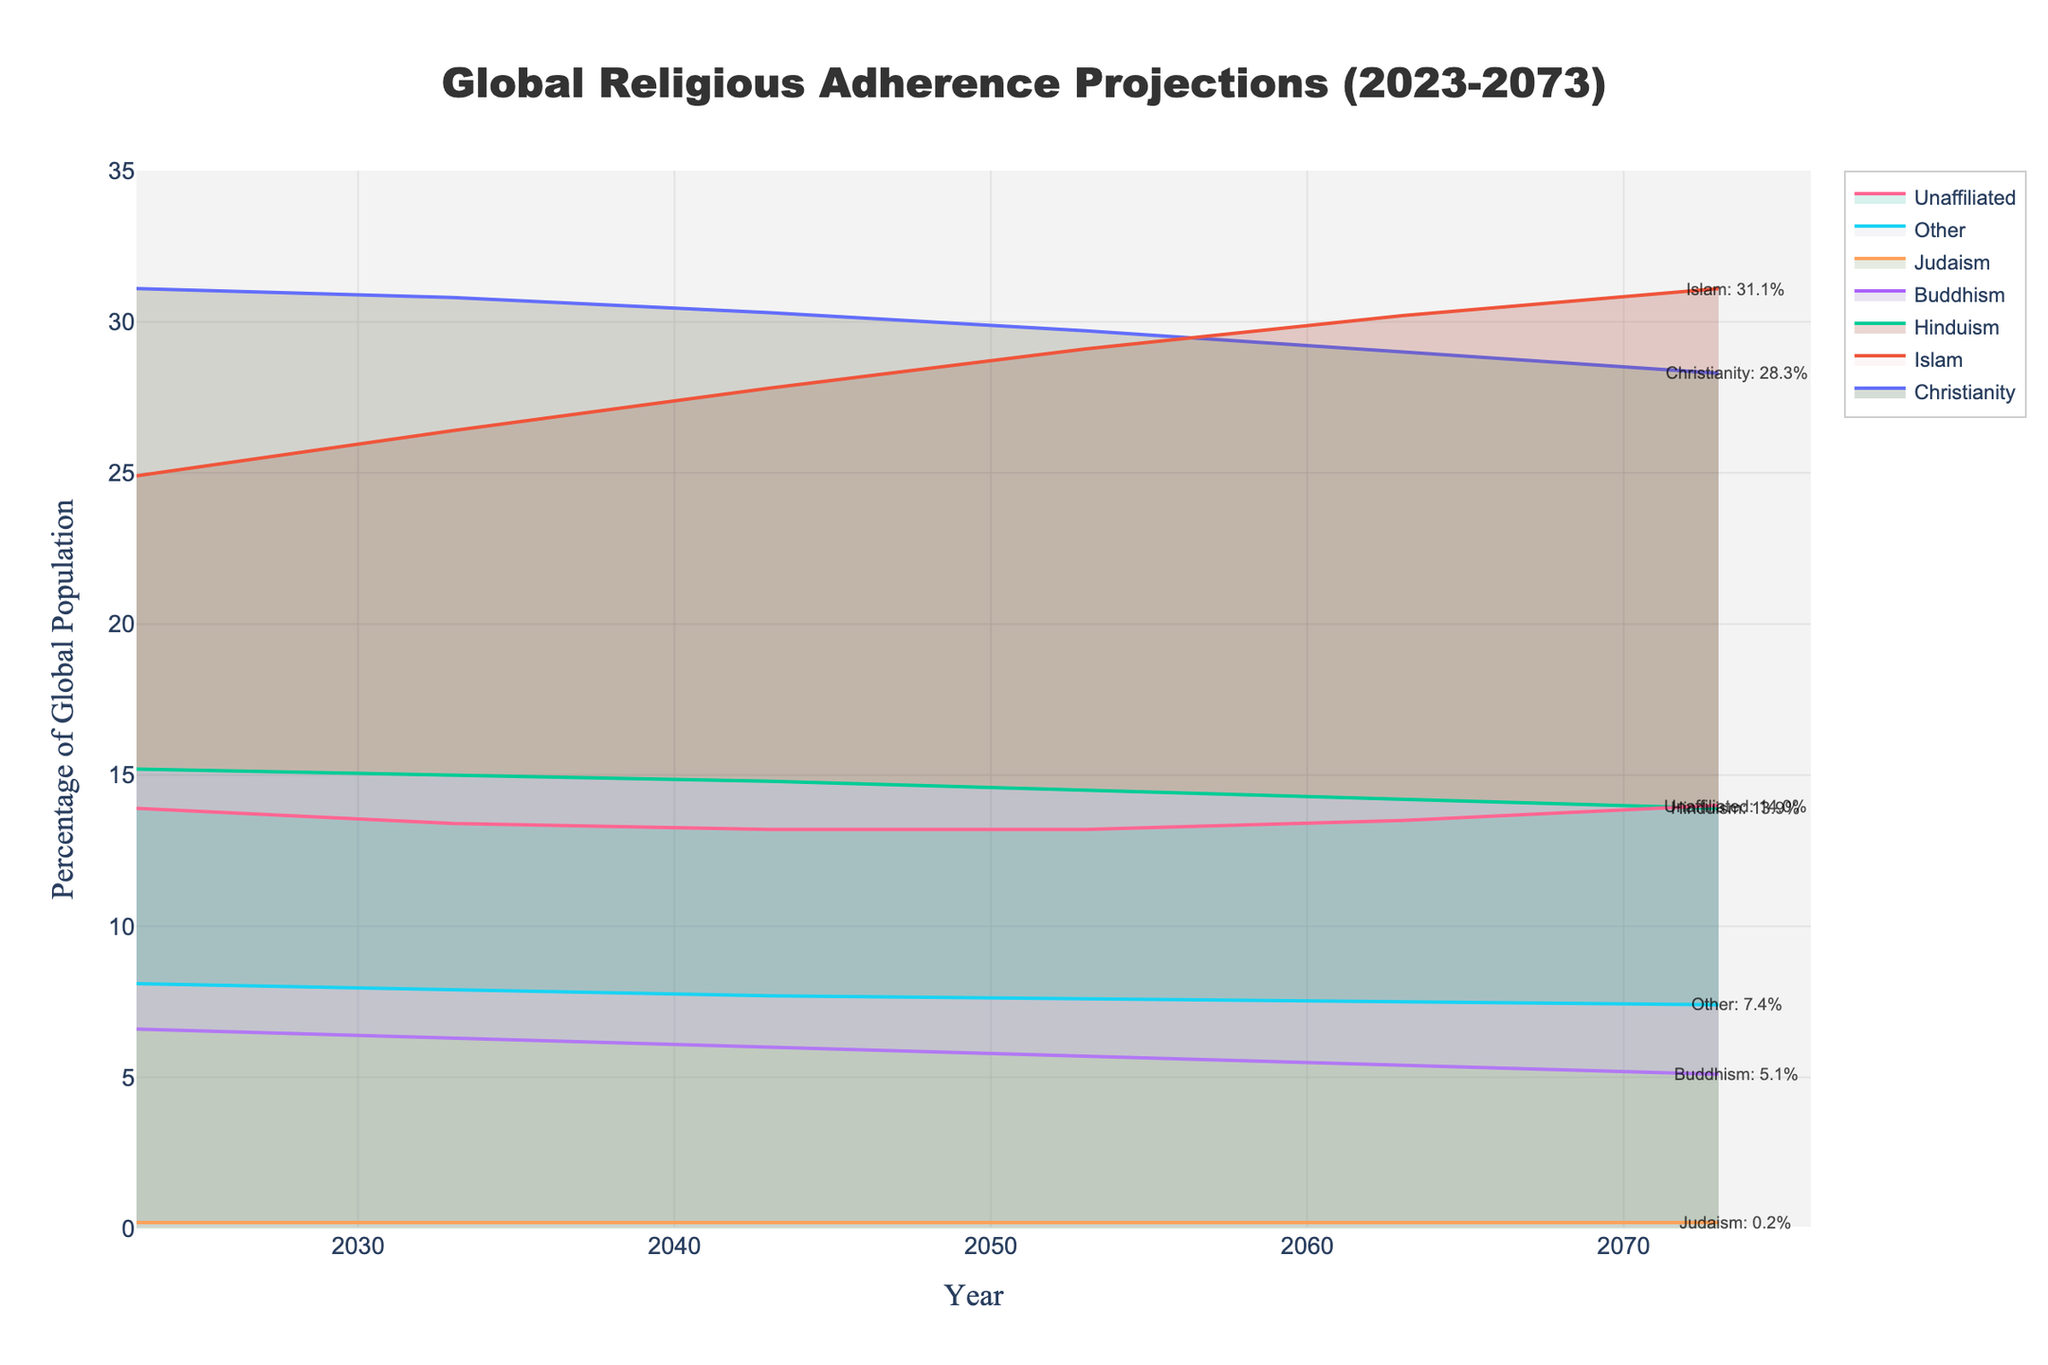What is the title of the figure? The title is typically displayed at the top of the figure. "Global Religious Adherence Projections (2023-2073)" is prominently shown in the code layout description.
Answer: Global Religious Adherence Projections (2023-2073) Which religion is projected to have the highest adherence in 2073? By visually scanning the lines in the chart and the annotations at the end of each line for the year 2073, Islam has the highest adherence at 31.1%.
Answer: Islam How much is the percentage of Christianity projected to decrease between 2023 and 2073? The chart shows the line for Christianity starting at 31.1% in 2023 and decreasing to 28.3% in 2073. The decrease can be calculated as 31.1% - 28.3% = 2.8%.
Answer: 2.8% What is the overall trend for the percentage of unaffiliated individuals? The line for 'Unaffiliated' shows a gradual increase, starting from 13.9% in 2023 and rising to 14.0% in 2073.
Answer: Gradually increasing In what year is the percentage of Buddhism projected to be 5.7%? Following the trend lines in the figure, the percentage for Buddhism intersects at 5.7% around the year 2053.
Answer: 2053 How does the projected growth of Hinduism compare to that of Judaism over 50 years? Comparing the lines for both religions, Hinduism shows a slight decrease from 15.2% to 13.9%, while Judaism remains stable at 0.2%.
Answer: Hinduism decreases, Judaism remains stable What is the combined percentage of all religions except 'Other' in 2073? The chart displays the percentages for each religion in 2073. Summing up Christianity (28.3%), Islam (31.1%), Hinduism (13.9%), Buddhism (5.1%), Judaism (0.2%), and Unaffiliated (14.0%), excluding 'Other': 28.3 + 31.1 + 13.9 + 5.1 + 0.2 + 14.0 = 92.6%.
Answer: 92.6% Between which two decades does Islam show the highest increase in percentage? Observing the slope of the line for Islam, the steepest increase happens between 2023 (24.9%) and 2033 (26.4%), which is an increase of 1.5%.
Answer: 2023 and 2033 What is the projected trend for the percentage of the 'Other' category? The line for 'Other' shows a slight decrease, crossing from 8.1% in 2023 to 7.4% in 2073.
Answer: Slightly decreasing 